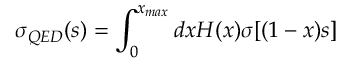Convert formula to latex. <formula><loc_0><loc_0><loc_500><loc_500>\sigma _ { Q E D } ( s ) = \int _ { 0 } ^ { x _ { \max } } d x H ( x ) \sigma [ ( 1 - x ) s ]</formula> 